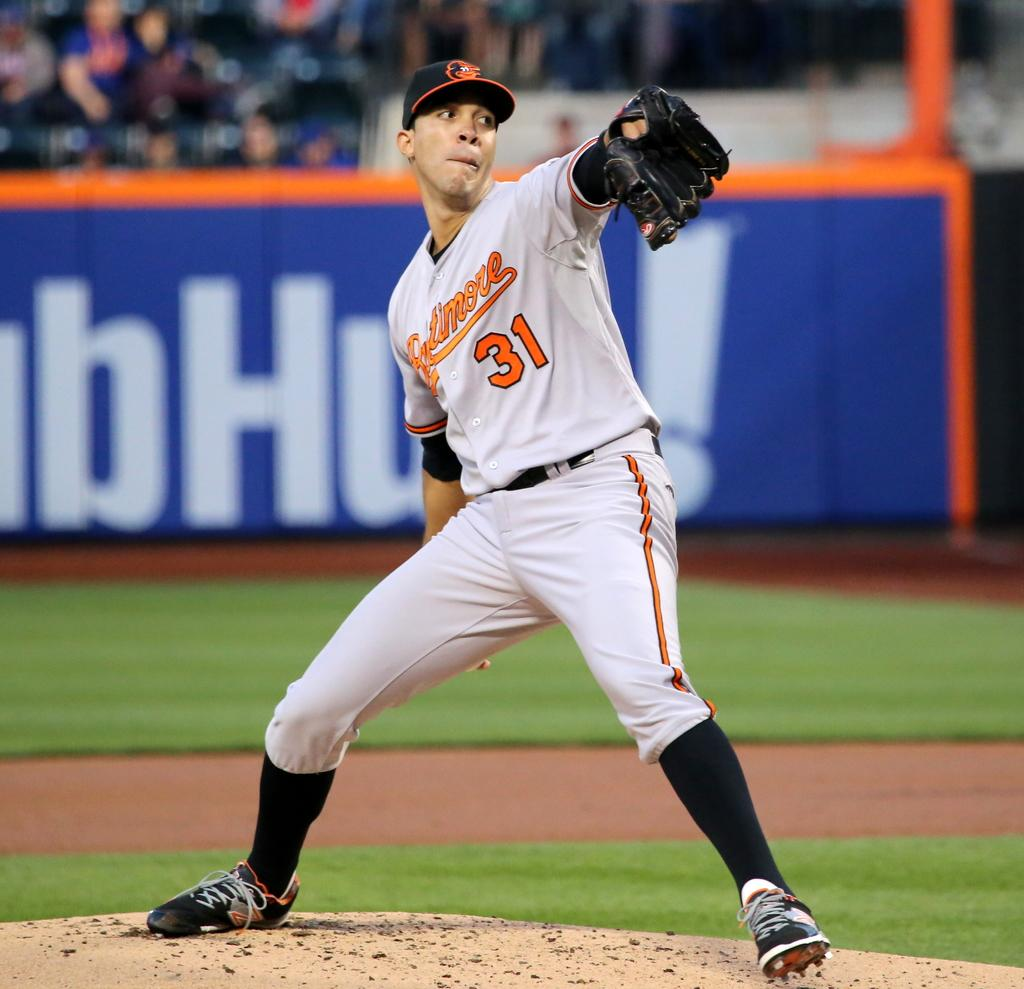<image>
Render a clear and concise summary of the photo. The pitcher is wearing a grey jersey with the number 31 